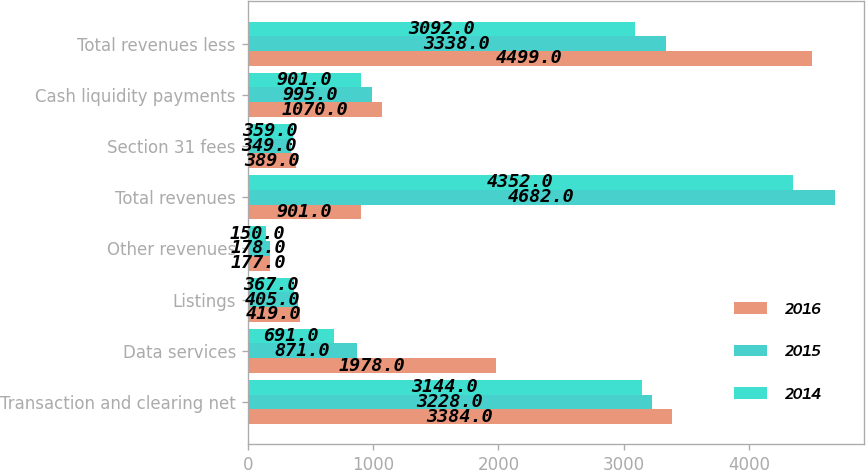Convert chart to OTSL. <chart><loc_0><loc_0><loc_500><loc_500><stacked_bar_chart><ecel><fcel>Transaction and clearing net<fcel>Data services<fcel>Listings<fcel>Other revenues<fcel>Total revenues<fcel>Section 31 fees<fcel>Cash liquidity payments<fcel>Total revenues less<nl><fcel>2016<fcel>3384<fcel>1978<fcel>419<fcel>177<fcel>901<fcel>389<fcel>1070<fcel>4499<nl><fcel>2015<fcel>3228<fcel>871<fcel>405<fcel>178<fcel>4682<fcel>349<fcel>995<fcel>3338<nl><fcel>2014<fcel>3144<fcel>691<fcel>367<fcel>150<fcel>4352<fcel>359<fcel>901<fcel>3092<nl></chart> 